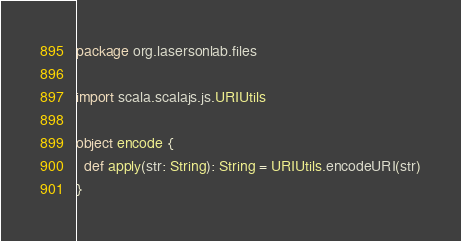Convert code to text. <code><loc_0><loc_0><loc_500><loc_500><_Scala_>package org.lasersonlab.files

import scala.scalajs.js.URIUtils

object encode {
  def apply(str: String): String = URIUtils.encodeURI(str)
}
</code> 